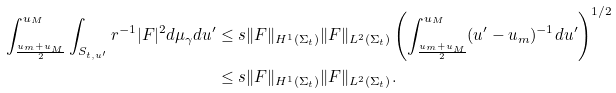<formula> <loc_0><loc_0><loc_500><loc_500>\int _ { \frac { u _ { m } + u _ { M } } { 2 } } ^ { u _ { M } } \int _ { S _ { t , u ^ { \prime } } } r ^ { - 1 } | F | ^ { 2 } d \mu _ { \gamma } d u ^ { \prime } & \leq s \| F \| _ { H ^ { 1 } ( \Sigma _ { t } ) } \| F \| _ { L ^ { 2 } ( \Sigma _ { t } ) } \left ( \int _ { \frac { u _ { m } + u _ { M } } { 2 } } ^ { u _ { M } } ( u ^ { \prime } - u _ { m } ) ^ { - 1 } d u ^ { \prime } \right ) ^ { 1 / 2 } \\ & \leq s \| F \| _ { H ^ { 1 } ( \Sigma _ { t } ) } \| F \| _ { L ^ { 2 } ( \Sigma _ { t } ) } .</formula> 